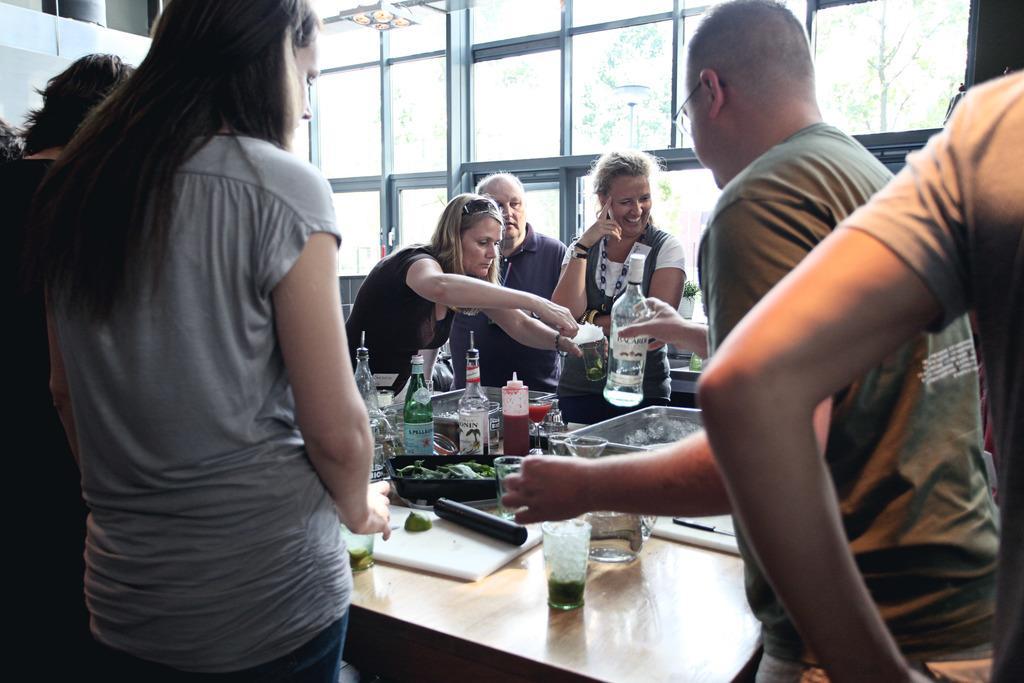How would you summarize this image in a sentence or two? There are group of people standing around the table which has eatables and some drinks on it. 